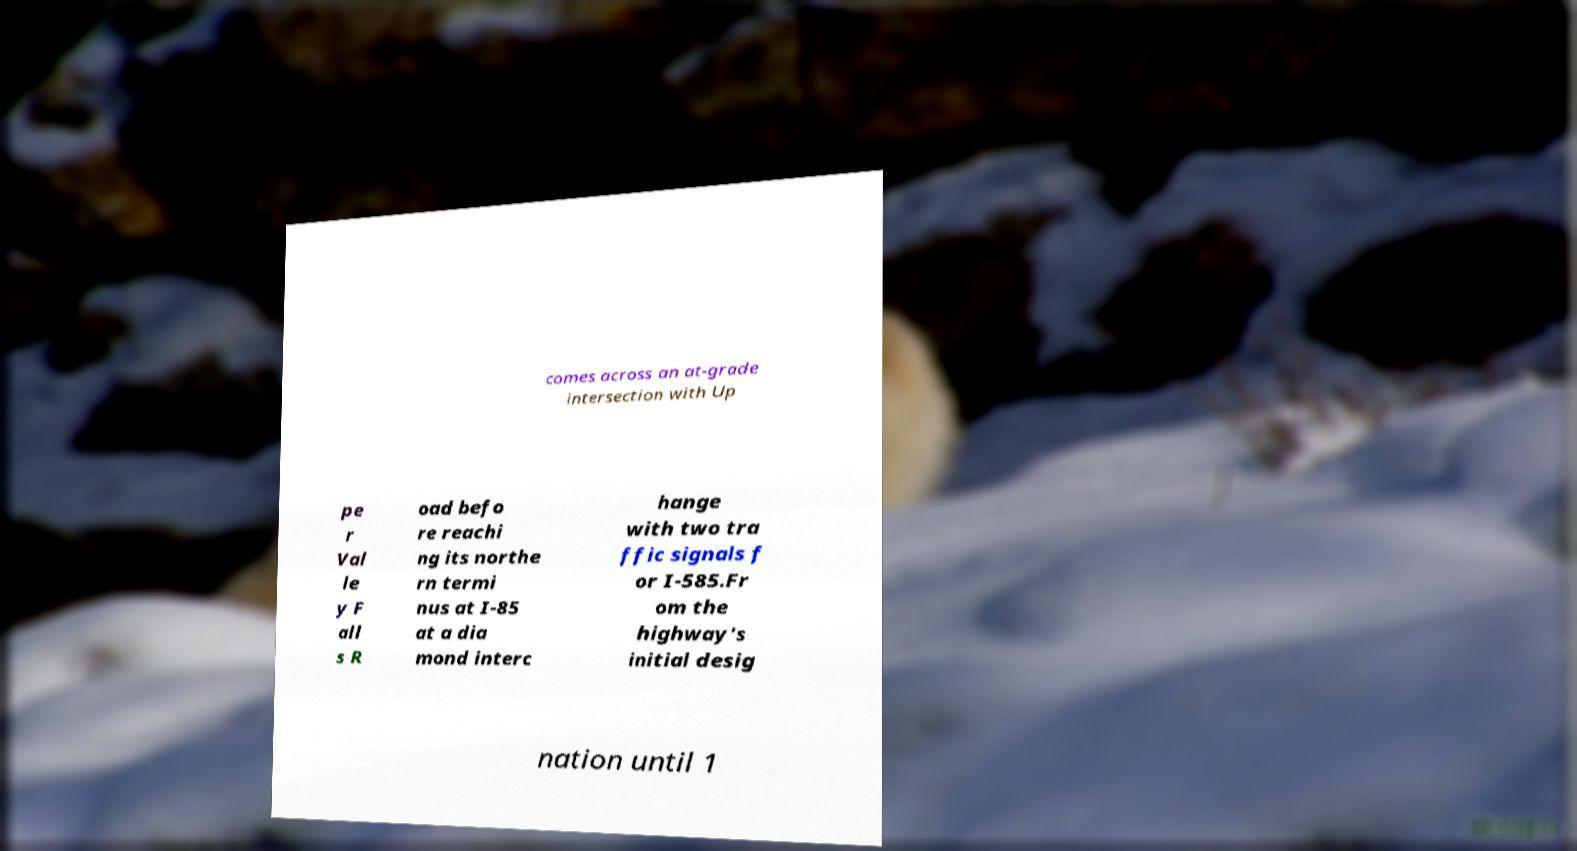Please identify and transcribe the text found in this image. comes across an at-grade intersection with Up pe r Val le y F all s R oad befo re reachi ng its northe rn termi nus at I-85 at a dia mond interc hange with two tra ffic signals f or I-585.Fr om the highway's initial desig nation until 1 